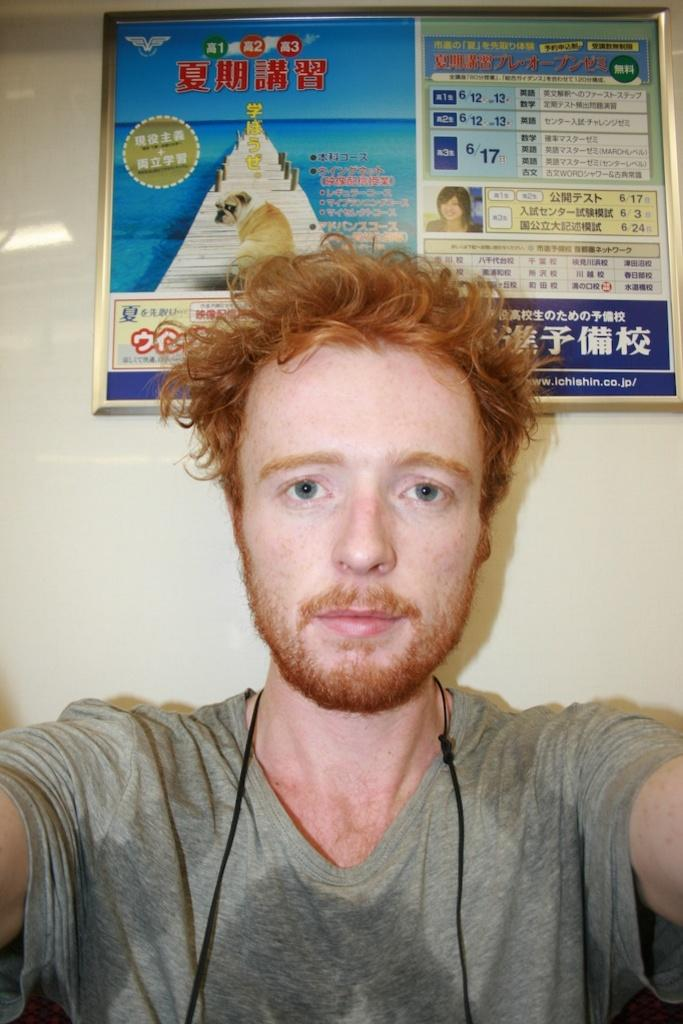Who is present in the image? There is a man in the image. What can be seen on the wall behind the man? There is a photo frame on the wall behind the man. What type of vase is placed on the table next to the man in the image? There is no vase present in the image; only the man and the photo frame on the wall are visible. 